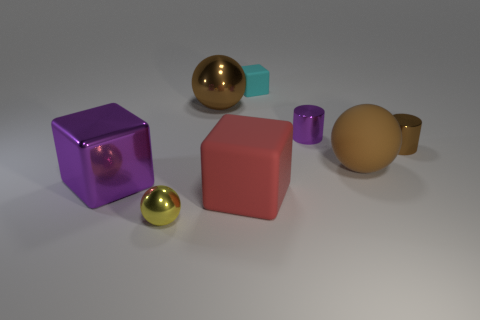Is there anything else that has the same size as the red rubber thing?
Provide a succinct answer. Yes. What is the material of the purple thing that is behind the ball right of the rubber cube that is on the left side of the tiny block?
Offer a terse response. Metal. Is the number of tiny objects in front of the small yellow thing greater than the number of yellow objects behind the cyan rubber cube?
Ensure brevity in your answer.  No. Do the brown matte object and the yellow shiny object have the same size?
Provide a succinct answer. No. There is another metallic thing that is the same shape as the yellow shiny thing; what color is it?
Ensure brevity in your answer.  Brown. How many large rubber things have the same color as the big metal block?
Keep it short and to the point. 0. Is the number of shiny objects on the right side of the brown cylinder greater than the number of big purple metallic cubes?
Provide a short and direct response. No. There is a block left of the matte block to the left of the tiny cyan object; what color is it?
Offer a terse response. Purple. How many things are either tiny shiny cylinders that are behind the brown cylinder or purple metallic things that are on the right side of the small ball?
Offer a terse response. 1. What color is the big metallic cube?
Give a very brief answer. Purple. 